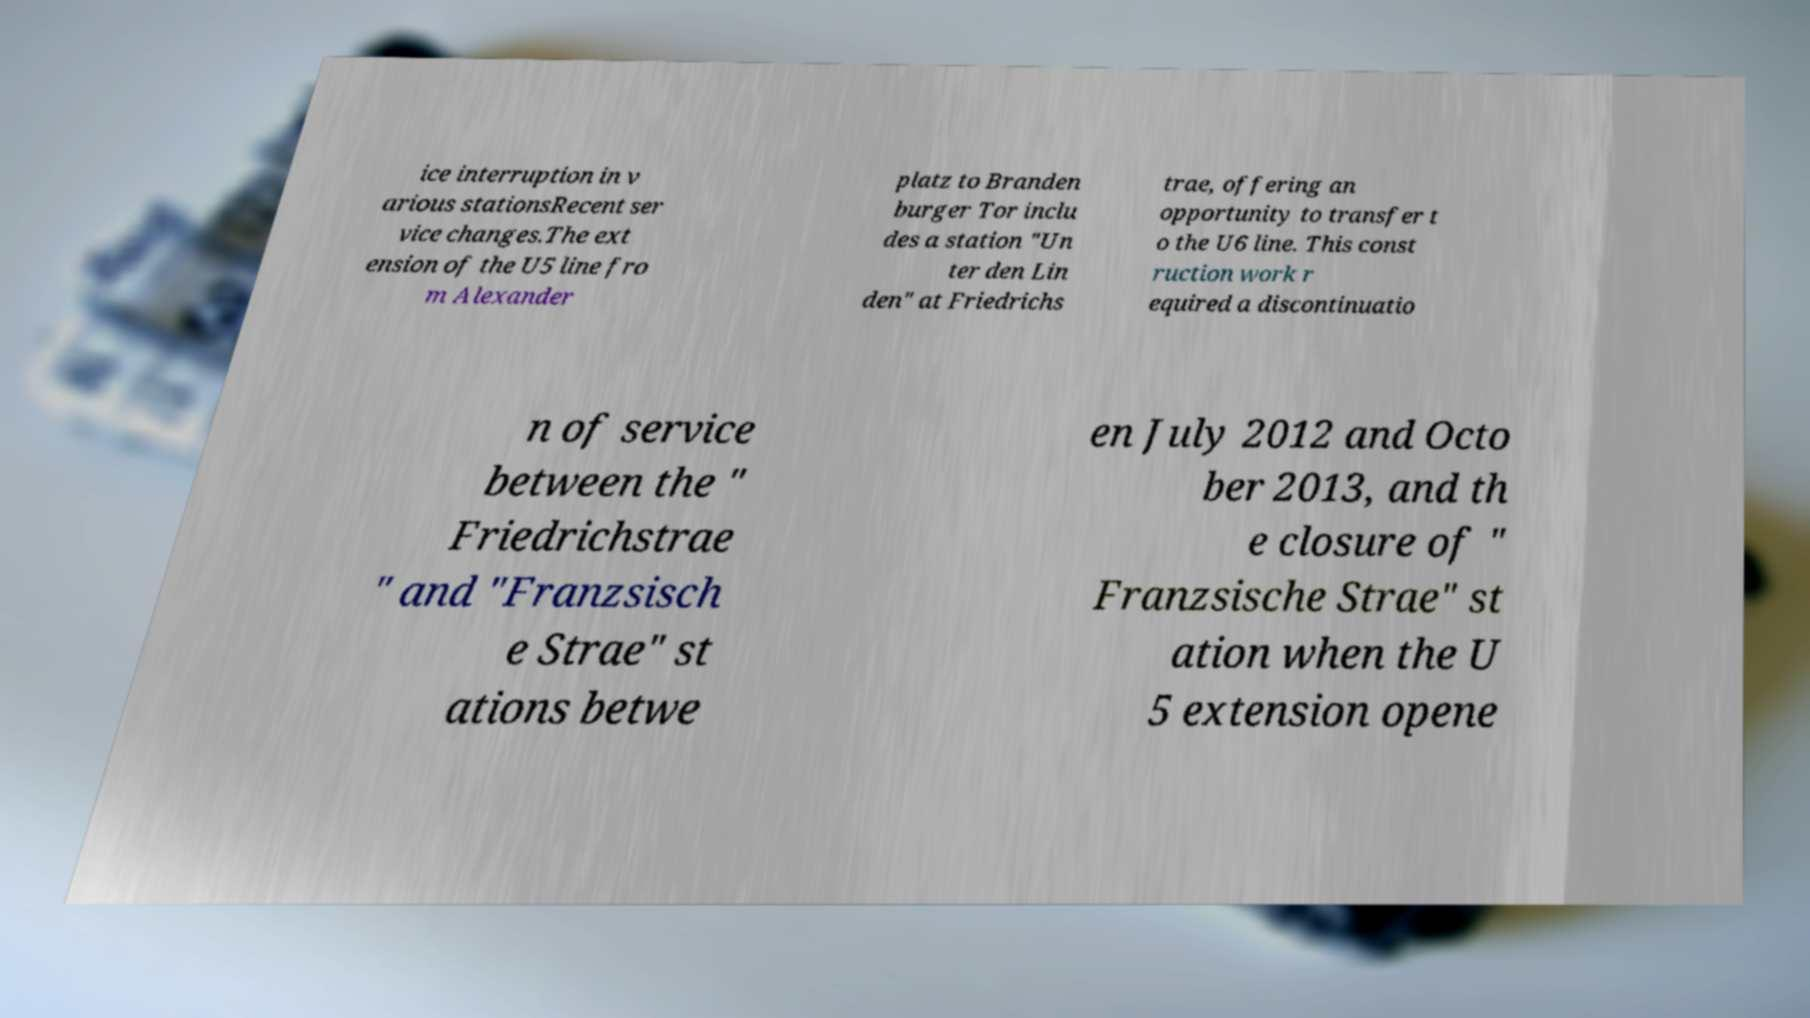Please read and relay the text visible in this image. What does it say? ice interruption in v arious stationsRecent ser vice changes.The ext ension of the U5 line fro m Alexander platz to Branden burger Tor inclu des a station "Un ter den Lin den" at Friedrichs trae, offering an opportunity to transfer t o the U6 line. This const ruction work r equired a discontinuatio n of service between the " Friedrichstrae " and "Franzsisch e Strae" st ations betwe en July 2012 and Octo ber 2013, and th e closure of " Franzsische Strae" st ation when the U 5 extension opene 